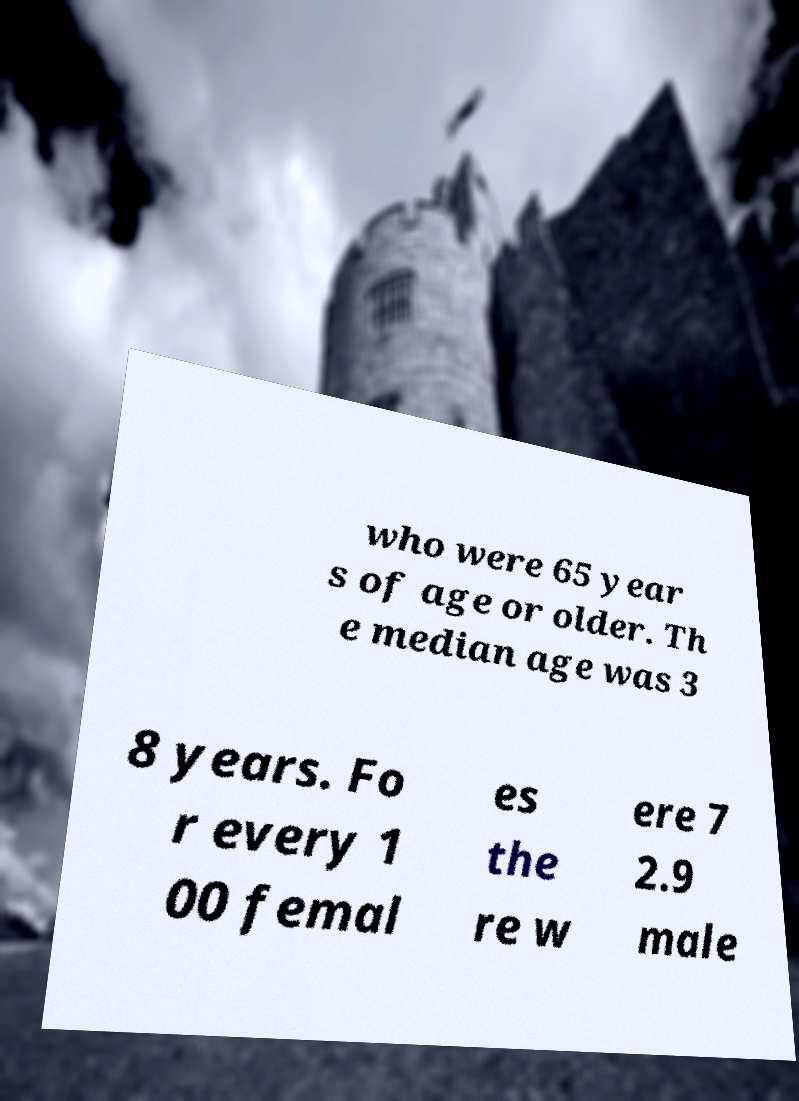Please identify and transcribe the text found in this image. who were 65 year s of age or older. Th e median age was 3 8 years. Fo r every 1 00 femal es the re w ere 7 2.9 male 